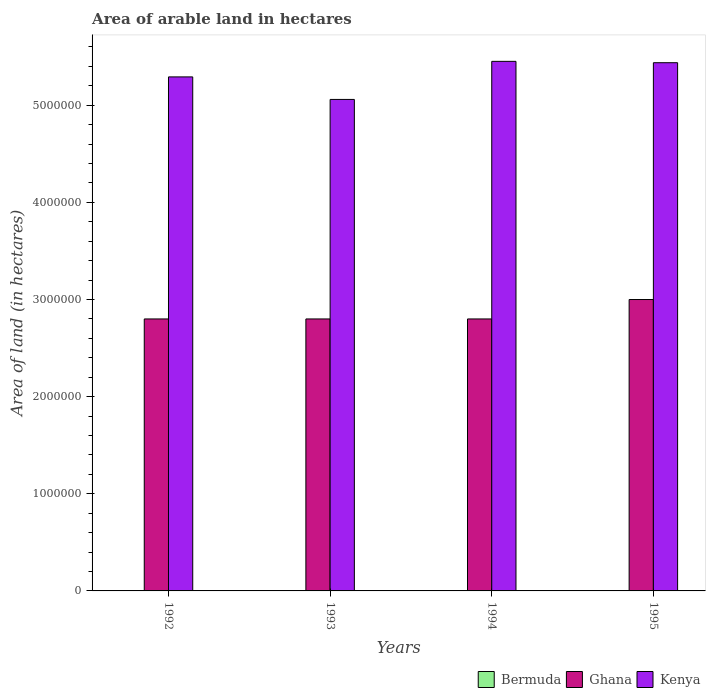How many different coloured bars are there?
Offer a terse response. 3. How many groups of bars are there?
Offer a very short reply. 4. Are the number of bars per tick equal to the number of legend labels?
Make the answer very short. Yes. How many bars are there on the 4th tick from the left?
Your answer should be compact. 3. How many bars are there on the 3rd tick from the right?
Your answer should be compact. 3. What is the label of the 1st group of bars from the left?
Your answer should be compact. 1992. What is the total arable land in Ghana in 1993?
Your response must be concise. 2.80e+06. Across all years, what is the maximum total arable land in Kenya?
Give a very brief answer. 5.45e+06. Across all years, what is the minimum total arable land in Kenya?
Provide a short and direct response. 5.06e+06. In which year was the total arable land in Ghana maximum?
Provide a short and direct response. 1995. In which year was the total arable land in Bermuda minimum?
Ensure brevity in your answer.  1992. What is the total total arable land in Bermuda in the graph?
Make the answer very short. 1300. What is the difference between the total arable land in Kenya in 1992 and the total arable land in Ghana in 1993?
Make the answer very short. 2.49e+06. What is the average total arable land in Ghana per year?
Your answer should be compact. 2.85e+06. In the year 1992, what is the difference between the total arable land in Ghana and total arable land in Bermuda?
Offer a very short reply. 2.80e+06. In how many years, is the total arable land in Ghana greater than 4000000 hectares?
Your answer should be compact. 0. What is the difference between the highest and the second highest total arable land in Bermuda?
Provide a short and direct response. 100. What is the difference between the highest and the lowest total arable land in Ghana?
Offer a very short reply. 2.00e+05. Is the sum of the total arable land in Kenya in 1994 and 1995 greater than the maximum total arable land in Ghana across all years?
Your response must be concise. Yes. What does the 2nd bar from the left in 1995 represents?
Make the answer very short. Ghana. What does the 2nd bar from the right in 1993 represents?
Your answer should be very brief. Ghana. Is it the case that in every year, the sum of the total arable land in Ghana and total arable land in Kenya is greater than the total arable land in Bermuda?
Make the answer very short. Yes. How many bars are there?
Give a very brief answer. 12. Are all the bars in the graph horizontal?
Provide a short and direct response. No. What is the title of the graph?
Provide a short and direct response. Area of arable land in hectares. What is the label or title of the X-axis?
Ensure brevity in your answer.  Years. What is the label or title of the Y-axis?
Provide a short and direct response. Area of land (in hectares). What is the Area of land (in hectares) of Bermuda in 1992?
Your answer should be compact. 300. What is the Area of land (in hectares) in Ghana in 1992?
Offer a very short reply. 2.80e+06. What is the Area of land (in hectares) of Kenya in 1992?
Make the answer very short. 5.29e+06. What is the Area of land (in hectares) in Bermuda in 1993?
Offer a very short reply. 300. What is the Area of land (in hectares) in Ghana in 1993?
Your answer should be very brief. 2.80e+06. What is the Area of land (in hectares) in Kenya in 1993?
Your answer should be very brief. 5.06e+06. What is the Area of land (in hectares) in Bermuda in 1994?
Keep it short and to the point. 300. What is the Area of land (in hectares) in Ghana in 1994?
Provide a succinct answer. 2.80e+06. What is the Area of land (in hectares) of Kenya in 1994?
Your response must be concise. 5.45e+06. What is the Area of land (in hectares) of Kenya in 1995?
Give a very brief answer. 5.44e+06. Across all years, what is the maximum Area of land (in hectares) of Kenya?
Offer a terse response. 5.45e+06. Across all years, what is the minimum Area of land (in hectares) in Bermuda?
Your answer should be very brief. 300. Across all years, what is the minimum Area of land (in hectares) of Ghana?
Your answer should be very brief. 2.80e+06. Across all years, what is the minimum Area of land (in hectares) in Kenya?
Keep it short and to the point. 5.06e+06. What is the total Area of land (in hectares) of Bermuda in the graph?
Provide a short and direct response. 1300. What is the total Area of land (in hectares) in Ghana in the graph?
Your response must be concise. 1.14e+07. What is the total Area of land (in hectares) of Kenya in the graph?
Provide a succinct answer. 2.12e+07. What is the difference between the Area of land (in hectares) in Bermuda in 1992 and that in 1993?
Offer a terse response. 0. What is the difference between the Area of land (in hectares) of Kenya in 1992 and that in 1993?
Keep it short and to the point. 2.32e+05. What is the difference between the Area of land (in hectares) of Ghana in 1992 and that in 1994?
Provide a short and direct response. 0. What is the difference between the Area of land (in hectares) in Kenya in 1992 and that in 1994?
Provide a short and direct response. -1.60e+05. What is the difference between the Area of land (in hectares) of Bermuda in 1992 and that in 1995?
Give a very brief answer. -100. What is the difference between the Area of land (in hectares) in Ghana in 1992 and that in 1995?
Your answer should be compact. -2.00e+05. What is the difference between the Area of land (in hectares) of Kenya in 1992 and that in 1995?
Give a very brief answer. -1.46e+05. What is the difference between the Area of land (in hectares) of Kenya in 1993 and that in 1994?
Ensure brevity in your answer.  -3.92e+05. What is the difference between the Area of land (in hectares) of Bermuda in 1993 and that in 1995?
Make the answer very short. -100. What is the difference between the Area of land (in hectares) of Kenya in 1993 and that in 1995?
Your response must be concise. -3.78e+05. What is the difference between the Area of land (in hectares) in Bermuda in 1994 and that in 1995?
Your answer should be very brief. -100. What is the difference between the Area of land (in hectares) of Kenya in 1994 and that in 1995?
Ensure brevity in your answer.  1.40e+04. What is the difference between the Area of land (in hectares) in Bermuda in 1992 and the Area of land (in hectares) in Ghana in 1993?
Offer a terse response. -2.80e+06. What is the difference between the Area of land (in hectares) of Bermuda in 1992 and the Area of land (in hectares) of Kenya in 1993?
Give a very brief answer. -5.06e+06. What is the difference between the Area of land (in hectares) in Ghana in 1992 and the Area of land (in hectares) in Kenya in 1993?
Your answer should be very brief. -2.26e+06. What is the difference between the Area of land (in hectares) in Bermuda in 1992 and the Area of land (in hectares) in Ghana in 1994?
Make the answer very short. -2.80e+06. What is the difference between the Area of land (in hectares) of Bermuda in 1992 and the Area of land (in hectares) of Kenya in 1994?
Your response must be concise. -5.45e+06. What is the difference between the Area of land (in hectares) of Ghana in 1992 and the Area of land (in hectares) of Kenya in 1994?
Provide a succinct answer. -2.65e+06. What is the difference between the Area of land (in hectares) of Bermuda in 1992 and the Area of land (in hectares) of Ghana in 1995?
Offer a terse response. -3.00e+06. What is the difference between the Area of land (in hectares) in Bermuda in 1992 and the Area of land (in hectares) in Kenya in 1995?
Make the answer very short. -5.44e+06. What is the difference between the Area of land (in hectares) of Ghana in 1992 and the Area of land (in hectares) of Kenya in 1995?
Ensure brevity in your answer.  -2.64e+06. What is the difference between the Area of land (in hectares) of Bermuda in 1993 and the Area of land (in hectares) of Ghana in 1994?
Your answer should be very brief. -2.80e+06. What is the difference between the Area of land (in hectares) in Bermuda in 1993 and the Area of land (in hectares) in Kenya in 1994?
Give a very brief answer. -5.45e+06. What is the difference between the Area of land (in hectares) in Ghana in 1993 and the Area of land (in hectares) in Kenya in 1994?
Provide a succinct answer. -2.65e+06. What is the difference between the Area of land (in hectares) in Bermuda in 1993 and the Area of land (in hectares) in Ghana in 1995?
Provide a succinct answer. -3.00e+06. What is the difference between the Area of land (in hectares) in Bermuda in 1993 and the Area of land (in hectares) in Kenya in 1995?
Ensure brevity in your answer.  -5.44e+06. What is the difference between the Area of land (in hectares) of Ghana in 1993 and the Area of land (in hectares) of Kenya in 1995?
Offer a terse response. -2.64e+06. What is the difference between the Area of land (in hectares) of Bermuda in 1994 and the Area of land (in hectares) of Ghana in 1995?
Your response must be concise. -3.00e+06. What is the difference between the Area of land (in hectares) in Bermuda in 1994 and the Area of land (in hectares) in Kenya in 1995?
Your answer should be very brief. -5.44e+06. What is the difference between the Area of land (in hectares) in Ghana in 1994 and the Area of land (in hectares) in Kenya in 1995?
Give a very brief answer. -2.64e+06. What is the average Area of land (in hectares) of Bermuda per year?
Ensure brevity in your answer.  325. What is the average Area of land (in hectares) of Ghana per year?
Offer a very short reply. 2.85e+06. What is the average Area of land (in hectares) of Kenya per year?
Offer a very short reply. 5.31e+06. In the year 1992, what is the difference between the Area of land (in hectares) of Bermuda and Area of land (in hectares) of Ghana?
Your answer should be very brief. -2.80e+06. In the year 1992, what is the difference between the Area of land (in hectares) of Bermuda and Area of land (in hectares) of Kenya?
Your answer should be compact. -5.29e+06. In the year 1992, what is the difference between the Area of land (in hectares) in Ghana and Area of land (in hectares) in Kenya?
Ensure brevity in your answer.  -2.49e+06. In the year 1993, what is the difference between the Area of land (in hectares) in Bermuda and Area of land (in hectares) in Ghana?
Provide a succinct answer. -2.80e+06. In the year 1993, what is the difference between the Area of land (in hectares) of Bermuda and Area of land (in hectares) of Kenya?
Offer a very short reply. -5.06e+06. In the year 1993, what is the difference between the Area of land (in hectares) of Ghana and Area of land (in hectares) of Kenya?
Ensure brevity in your answer.  -2.26e+06. In the year 1994, what is the difference between the Area of land (in hectares) of Bermuda and Area of land (in hectares) of Ghana?
Provide a short and direct response. -2.80e+06. In the year 1994, what is the difference between the Area of land (in hectares) in Bermuda and Area of land (in hectares) in Kenya?
Offer a terse response. -5.45e+06. In the year 1994, what is the difference between the Area of land (in hectares) in Ghana and Area of land (in hectares) in Kenya?
Your answer should be very brief. -2.65e+06. In the year 1995, what is the difference between the Area of land (in hectares) of Bermuda and Area of land (in hectares) of Ghana?
Ensure brevity in your answer.  -3.00e+06. In the year 1995, what is the difference between the Area of land (in hectares) of Bermuda and Area of land (in hectares) of Kenya?
Your answer should be compact. -5.44e+06. In the year 1995, what is the difference between the Area of land (in hectares) in Ghana and Area of land (in hectares) in Kenya?
Offer a very short reply. -2.44e+06. What is the ratio of the Area of land (in hectares) of Ghana in 1992 to that in 1993?
Provide a short and direct response. 1. What is the ratio of the Area of land (in hectares) in Kenya in 1992 to that in 1993?
Your response must be concise. 1.05. What is the ratio of the Area of land (in hectares) of Bermuda in 1992 to that in 1994?
Keep it short and to the point. 1. What is the ratio of the Area of land (in hectares) of Kenya in 1992 to that in 1994?
Your answer should be very brief. 0.97. What is the ratio of the Area of land (in hectares) of Bermuda in 1992 to that in 1995?
Provide a succinct answer. 0.75. What is the ratio of the Area of land (in hectares) of Ghana in 1992 to that in 1995?
Offer a very short reply. 0.93. What is the ratio of the Area of land (in hectares) in Kenya in 1992 to that in 1995?
Make the answer very short. 0.97. What is the ratio of the Area of land (in hectares) in Kenya in 1993 to that in 1994?
Make the answer very short. 0.93. What is the ratio of the Area of land (in hectares) of Ghana in 1993 to that in 1995?
Your answer should be compact. 0.93. What is the ratio of the Area of land (in hectares) in Kenya in 1993 to that in 1995?
Your response must be concise. 0.93. What is the ratio of the Area of land (in hectares) of Bermuda in 1994 to that in 1995?
Give a very brief answer. 0.75. What is the ratio of the Area of land (in hectares) of Ghana in 1994 to that in 1995?
Offer a very short reply. 0.93. What is the difference between the highest and the second highest Area of land (in hectares) of Kenya?
Provide a short and direct response. 1.40e+04. What is the difference between the highest and the lowest Area of land (in hectares) of Ghana?
Your answer should be compact. 2.00e+05. What is the difference between the highest and the lowest Area of land (in hectares) of Kenya?
Provide a succinct answer. 3.92e+05. 